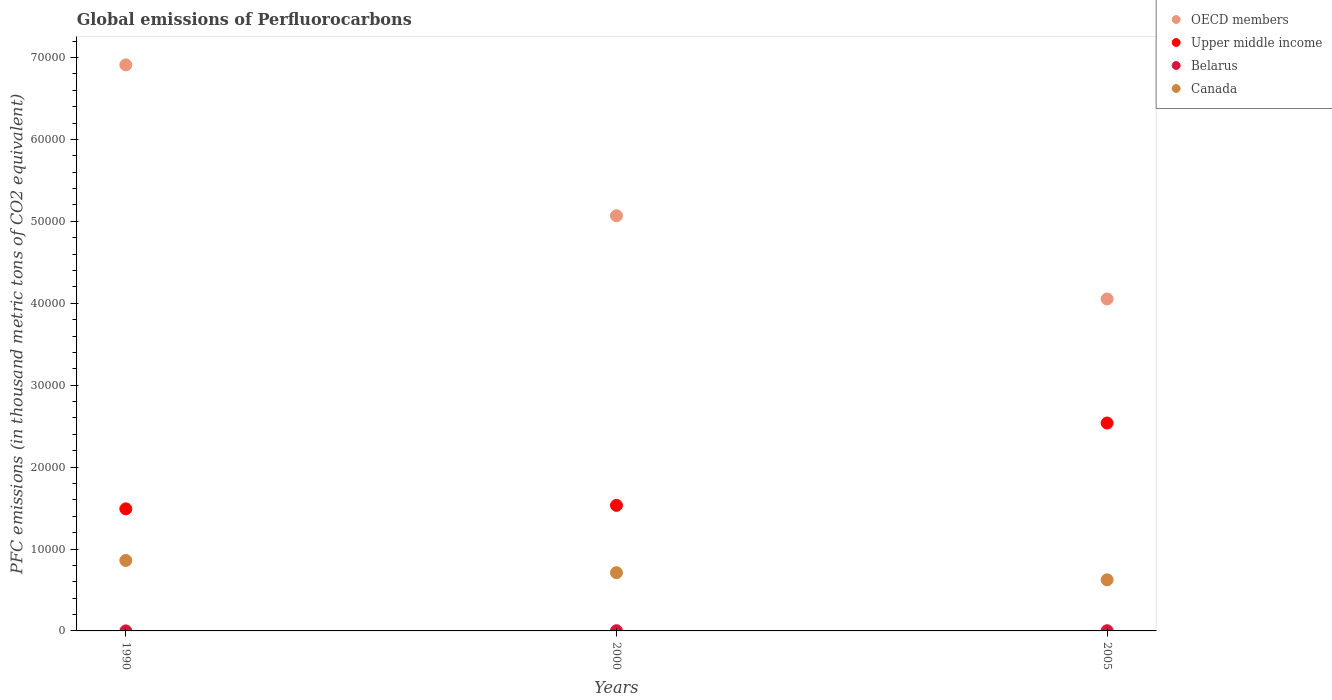Is the number of dotlines equal to the number of legend labels?
Keep it short and to the point. Yes. What is the global emissions of Perfluorocarbons in Belarus in 2005?
Your answer should be very brief. 23.4. Across all years, what is the maximum global emissions of Perfluorocarbons in Belarus?
Your answer should be very brief. 23.9. Across all years, what is the minimum global emissions of Perfluorocarbons in Upper middle income?
Provide a short and direct response. 1.49e+04. In which year was the global emissions of Perfluorocarbons in Belarus maximum?
Your answer should be compact. 2000. In which year was the global emissions of Perfluorocarbons in Canada minimum?
Your answer should be very brief. 2005. What is the total global emissions of Perfluorocarbons in Upper middle income in the graph?
Provide a short and direct response. 5.56e+04. What is the difference between the global emissions of Perfluorocarbons in Canada in 2000 and that in 2005?
Offer a terse response. 871.9. What is the difference between the global emissions of Perfluorocarbons in Canada in 2005 and the global emissions of Perfluorocarbons in Upper middle income in 1990?
Keep it short and to the point. -8662.6. What is the average global emissions of Perfluorocarbons in Upper middle income per year?
Your response must be concise. 1.85e+04. In the year 1990, what is the difference between the global emissions of Perfluorocarbons in Belarus and global emissions of Perfluorocarbons in OECD members?
Your response must be concise. -6.91e+04. In how many years, is the global emissions of Perfluorocarbons in Belarus greater than 20000 thousand metric tons?
Your response must be concise. 0. What is the ratio of the global emissions of Perfluorocarbons in Upper middle income in 2000 to that in 2005?
Provide a short and direct response. 0.6. Is the difference between the global emissions of Perfluorocarbons in Belarus in 1990 and 2005 greater than the difference between the global emissions of Perfluorocarbons in OECD members in 1990 and 2005?
Provide a short and direct response. No. What is the difference between the highest and the second highest global emissions of Perfluorocarbons in Upper middle income?
Ensure brevity in your answer.  1.01e+04. What is the difference between the highest and the lowest global emissions of Perfluorocarbons in Upper middle income?
Provide a succinct answer. 1.05e+04. Is it the case that in every year, the sum of the global emissions of Perfluorocarbons in Upper middle income and global emissions of Perfluorocarbons in Belarus  is greater than the sum of global emissions of Perfluorocarbons in OECD members and global emissions of Perfluorocarbons in Canada?
Keep it short and to the point. No. Is it the case that in every year, the sum of the global emissions of Perfluorocarbons in Belarus and global emissions of Perfluorocarbons in OECD members  is greater than the global emissions of Perfluorocarbons in Upper middle income?
Provide a succinct answer. Yes. Does the global emissions of Perfluorocarbons in Canada monotonically increase over the years?
Make the answer very short. No. Is the global emissions of Perfluorocarbons in Belarus strictly less than the global emissions of Perfluorocarbons in OECD members over the years?
Offer a terse response. Yes. How many dotlines are there?
Offer a terse response. 4. How many years are there in the graph?
Give a very brief answer. 3. What is the difference between two consecutive major ticks on the Y-axis?
Offer a very short reply. 10000. Are the values on the major ticks of Y-axis written in scientific E-notation?
Ensure brevity in your answer.  No. Does the graph contain grids?
Provide a short and direct response. No. Where does the legend appear in the graph?
Your response must be concise. Top right. What is the title of the graph?
Your response must be concise. Global emissions of Perfluorocarbons. Does "World" appear as one of the legend labels in the graph?
Provide a short and direct response. No. What is the label or title of the Y-axis?
Ensure brevity in your answer.  PFC emissions (in thousand metric tons of CO2 equivalent). What is the PFC emissions (in thousand metric tons of CO2 equivalent) of OECD members in 1990?
Make the answer very short. 6.91e+04. What is the PFC emissions (in thousand metric tons of CO2 equivalent) of Upper middle income in 1990?
Make the answer very short. 1.49e+04. What is the PFC emissions (in thousand metric tons of CO2 equivalent) in Belarus in 1990?
Give a very brief answer. 2.6. What is the PFC emissions (in thousand metric tons of CO2 equivalent) of Canada in 1990?
Offer a very short reply. 8600.3. What is the PFC emissions (in thousand metric tons of CO2 equivalent) of OECD members in 2000?
Offer a terse response. 5.07e+04. What is the PFC emissions (in thousand metric tons of CO2 equivalent) of Upper middle income in 2000?
Give a very brief answer. 1.53e+04. What is the PFC emissions (in thousand metric tons of CO2 equivalent) in Belarus in 2000?
Give a very brief answer. 23.9. What is the PFC emissions (in thousand metric tons of CO2 equivalent) in Canada in 2000?
Offer a very short reply. 7109.9. What is the PFC emissions (in thousand metric tons of CO2 equivalent) in OECD members in 2005?
Keep it short and to the point. 4.05e+04. What is the PFC emissions (in thousand metric tons of CO2 equivalent) of Upper middle income in 2005?
Your answer should be compact. 2.54e+04. What is the PFC emissions (in thousand metric tons of CO2 equivalent) in Belarus in 2005?
Provide a short and direct response. 23.4. What is the PFC emissions (in thousand metric tons of CO2 equivalent) in Canada in 2005?
Your answer should be compact. 6238. Across all years, what is the maximum PFC emissions (in thousand metric tons of CO2 equivalent) in OECD members?
Provide a short and direct response. 6.91e+04. Across all years, what is the maximum PFC emissions (in thousand metric tons of CO2 equivalent) in Upper middle income?
Provide a short and direct response. 2.54e+04. Across all years, what is the maximum PFC emissions (in thousand metric tons of CO2 equivalent) of Belarus?
Your response must be concise. 23.9. Across all years, what is the maximum PFC emissions (in thousand metric tons of CO2 equivalent) of Canada?
Provide a short and direct response. 8600.3. Across all years, what is the minimum PFC emissions (in thousand metric tons of CO2 equivalent) in OECD members?
Make the answer very short. 4.05e+04. Across all years, what is the minimum PFC emissions (in thousand metric tons of CO2 equivalent) of Upper middle income?
Provide a short and direct response. 1.49e+04. Across all years, what is the minimum PFC emissions (in thousand metric tons of CO2 equivalent) in Canada?
Provide a short and direct response. 6238. What is the total PFC emissions (in thousand metric tons of CO2 equivalent) in OECD members in the graph?
Ensure brevity in your answer.  1.60e+05. What is the total PFC emissions (in thousand metric tons of CO2 equivalent) of Upper middle income in the graph?
Give a very brief answer. 5.56e+04. What is the total PFC emissions (in thousand metric tons of CO2 equivalent) in Belarus in the graph?
Offer a very short reply. 49.9. What is the total PFC emissions (in thousand metric tons of CO2 equivalent) in Canada in the graph?
Ensure brevity in your answer.  2.19e+04. What is the difference between the PFC emissions (in thousand metric tons of CO2 equivalent) of OECD members in 1990 and that in 2000?
Provide a succinct answer. 1.84e+04. What is the difference between the PFC emissions (in thousand metric tons of CO2 equivalent) of Upper middle income in 1990 and that in 2000?
Keep it short and to the point. -426.2. What is the difference between the PFC emissions (in thousand metric tons of CO2 equivalent) in Belarus in 1990 and that in 2000?
Provide a short and direct response. -21.3. What is the difference between the PFC emissions (in thousand metric tons of CO2 equivalent) of Canada in 1990 and that in 2000?
Give a very brief answer. 1490.4. What is the difference between the PFC emissions (in thousand metric tons of CO2 equivalent) in OECD members in 1990 and that in 2005?
Your answer should be compact. 2.86e+04. What is the difference between the PFC emissions (in thousand metric tons of CO2 equivalent) in Upper middle income in 1990 and that in 2005?
Your answer should be very brief. -1.05e+04. What is the difference between the PFC emissions (in thousand metric tons of CO2 equivalent) in Belarus in 1990 and that in 2005?
Ensure brevity in your answer.  -20.8. What is the difference between the PFC emissions (in thousand metric tons of CO2 equivalent) of Canada in 1990 and that in 2005?
Your answer should be very brief. 2362.3. What is the difference between the PFC emissions (in thousand metric tons of CO2 equivalent) of OECD members in 2000 and that in 2005?
Provide a short and direct response. 1.02e+04. What is the difference between the PFC emissions (in thousand metric tons of CO2 equivalent) in Upper middle income in 2000 and that in 2005?
Your response must be concise. -1.01e+04. What is the difference between the PFC emissions (in thousand metric tons of CO2 equivalent) of Canada in 2000 and that in 2005?
Give a very brief answer. 871.9. What is the difference between the PFC emissions (in thousand metric tons of CO2 equivalent) in OECD members in 1990 and the PFC emissions (in thousand metric tons of CO2 equivalent) in Upper middle income in 2000?
Your response must be concise. 5.38e+04. What is the difference between the PFC emissions (in thousand metric tons of CO2 equivalent) in OECD members in 1990 and the PFC emissions (in thousand metric tons of CO2 equivalent) in Belarus in 2000?
Make the answer very short. 6.91e+04. What is the difference between the PFC emissions (in thousand metric tons of CO2 equivalent) in OECD members in 1990 and the PFC emissions (in thousand metric tons of CO2 equivalent) in Canada in 2000?
Ensure brevity in your answer.  6.20e+04. What is the difference between the PFC emissions (in thousand metric tons of CO2 equivalent) of Upper middle income in 1990 and the PFC emissions (in thousand metric tons of CO2 equivalent) of Belarus in 2000?
Make the answer very short. 1.49e+04. What is the difference between the PFC emissions (in thousand metric tons of CO2 equivalent) in Upper middle income in 1990 and the PFC emissions (in thousand metric tons of CO2 equivalent) in Canada in 2000?
Keep it short and to the point. 7790.7. What is the difference between the PFC emissions (in thousand metric tons of CO2 equivalent) in Belarus in 1990 and the PFC emissions (in thousand metric tons of CO2 equivalent) in Canada in 2000?
Keep it short and to the point. -7107.3. What is the difference between the PFC emissions (in thousand metric tons of CO2 equivalent) of OECD members in 1990 and the PFC emissions (in thousand metric tons of CO2 equivalent) of Upper middle income in 2005?
Your response must be concise. 4.37e+04. What is the difference between the PFC emissions (in thousand metric tons of CO2 equivalent) in OECD members in 1990 and the PFC emissions (in thousand metric tons of CO2 equivalent) in Belarus in 2005?
Make the answer very short. 6.91e+04. What is the difference between the PFC emissions (in thousand metric tons of CO2 equivalent) of OECD members in 1990 and the PFC emissions (in thousand metric tons of CO2 equivalent) of Canada in 2005?
Give a very brief answer. 6.29e+04. What is the difference between the PFC emissions (in thousand metric tons of CO2 equivalent) of Upper middle income in 1990 and the PFC emissions (in thousand metric tons of CO2 equivalent) of Belarus in 2005?
Offer a very short reply. 1.49e+04. What is the difference between the PFC emissions (in thousand metric tons of CO2 equivalent) in Upper middle income in 1990 and the PFC emissions (in thousand metric tons of CO2 equivalent) in Canada in 2005?
Provide a short and direct response. 8662.6. What is the difference between the PFC emissions (in thousand metric tons of CO2 equivalent) in Belarus in 1990 and the PFC emissions (in thousand metric tons of CO2 equivalent) in Canada in 2005?
Provide a succinct answer. -6235.4. What is the difference between the PFC emissions (in thousand metric tons of CO2 equivalent) of OECD members in 2000 and the PFC emissions (in thousand metric tons of CO2 equivalent) of Upper middle income in 2005?
Offer a very short reply. 2.53e+04. What is the difference between the PFC emissions (in thousand metric tons of CO2 equivalent) in OECD members in 2000 and the PFC emissions (in thousand metric tons of CO2 equivalent) in Belarus in 2005?
Offer a very short reply. 5.07e+04. What is the difference between the PFC emissions (in thousand metric tons of CO2 equivalent) in OECD members in 2000 and the PFC emissions (in thousand metric tons of CO2 equivalent) in Canada in 2005?
Your response must be concise. 4.44e+04. What is the difference between the PFC emissions (in thousand metric tons of CO2 equivalent) in Upper middle income in 2000 and the PFC emissions (in thousand metric tons of CO2 equivalent) in Belarus in 2005?
Your answer should be compact. 1.53e+04. What is the difference between the PFC emissions (in thousand metric tons of CO2 equivalent) of Upper middle income in 2000 and the PFC emissions (in thousand metric tons of CO2 equivalent) of Canada in 2005?
Your response must be concise. 9088.8. What is the difference between the PFC emissions (in thousand metric tons of CO2 equivalent) of Belarus in 2000 and the PFC emissions (in thousand metric tons of CO2 equivalent) of Canada in 2005?
Your response must be concise. -6214.1. What is the average PFC emissions (in thousand metric tons of CO2 equivalent) of OECD members per year?
Make the answer very short. 5.34e+04. What is the average PFC emissions (in thousand metric tons of CO2 equivalent) of Upper middle income per year?
Offer a very short reply. 1.85e+04. What is the average PFC emissions (in thousand metric tons of CO2 equivalent) of Belarus per year?
Offer a very short reply. 16.63. What is the average PFC emissions (in thousand metric tons of CO2 equivalent) of Canada per year?
Your answer should be very brief. 7316.07. In the year 1990, what is the difference between the PFC emissions (in thousand metric tons of CO2 equivalent) of OECD members and PFC emissions (in thousand metric tons of CO2 equivalent) of Upper middle income?
Your response must be concise. 5.42e+04. In the year 1990, what is the difference between the PFC emissions (in thousand metric tons of CO2 equivalent) of OECD members and PFC emissions (in thousand metric tons of CO2 equivalent) of Belarus?
Your response must be concise. 6.91e+04. In the year 1990, what is the difference between the PFC emissions (in thousand metric tons of CO2 equivalent) of OECD members and PFC emissions (in thousand metric tons of CO2 equivalent) of Canada?
Your answer should be very brief. 6.05e+04. In the year 1990, what is the difference between the PFC emissions (in thousand metric tons of CO2 equivalent) in Upper middle income and PFC emissions (in thousand metric tons of CO2 equivalent) in Belarus?
Make the answer very short. 1.49e+04. In the year 1990, what is the difference between the PFC emissions (in thousand metric tons of CO2 equivalent) of Upper middle income and PFC emissions (in thousand metric tons of CO2 equivalent) of Canada?
Offer a terse response. 6300.3. In the year 1990, what is the difference between the PFC emissions (in thousand metric tons of CO2 equivalent) of Belarus and PFC emissions (in thousand metric tons of CO2 equivalent) of Canada?
Your response must be concise. -8597.7. In the year 2000, what is the difference between the PFC emissions (in thousand metric tons of CO2 equivalent) of OECD members and PFC emissions (in thousand metric tons of CO2 equivalent) of Upper middle income?
Your answer should be very brief. 3.54e+04. In the year 2000, what is the difference between the PFC emissions (in thousand metric tons of CO2 equivalent) of OECD members and PFC emissions (in thousand metric tons of CO2 equivalent) of Belarus?
Ensure brevity in your answer.  5.07e+04. In the year 2000, what is the difference between the PFC emissions (in thousand metric tons of CO2 equivalent) in OECD members and PFC emissions (in thousand metric tons of CO2 equivalent) in Canada?
Keep it short and to the point. 4.36e+04. In the year 2000, what is the difference between the PFC emissions (in thousand metric tons of CO2 equivalent) of Upper middle income and PFC emissions (in thousand metric tons of CO2 equivalent) of Belarus?
Your answer should be very brief. 1.53e+04. In the year 2000, what is the difference between the PFC emissions (in thousand metric tons of CO2 equivalent) of Upper middle income and PFC emissions (in thousand metric tons of CO2 equivalent) of Canada?
Your answer should be compact. 8216.9. In the year 2000, what is the difference between the PFC emissions (in thousand metric tons of CO2 equivalent) of Belarus and PFC emissions (in thousand metric tons of CO2 equivalent) of Canada?
Offer a terse response. -7086. In the year 2005, what is the difference between the PFC emissions (in thousand metric tons of CO2 equivalent) in OECD members and PFC emissions (in thousand metric tons of CO2 equivalent) in Upper middle income?
Offer a terse response. 1.51e+04. In the year 2005, what is the difference between the PFC emissions (in thousand metric tons of CO2 equivalent) of OECD members and PFC emissions (in thousand metric tons of CO2 equivalent) of Belarus?
Give a very brief answer. 4.05e+04. In the year 2005, what is the difference between the PFC emissions (in thousand metric tons of CO2 equivalent) in OECD members and PFC emissions (in thousand metric tons of CO2 equivalent) in Canada?
Offer a terse response. 3.43e+04. In the year 2005, what is the difference between the PFC emissions (in thousand metric tons of CO2 equivalent) of Upper middle income and PFC emissions (in thousand metric tons of CO2 equivalent) of Belarus?
Your answer should be very brief. 2.54e+04. In the year 2005, what is the difference between the PFC emissions (in thousand metric tons of CO2 equivalent) in Upper middle income and PFC emissions (in thousand metric tons of CO2 equivalent) in Canada?
Provide a succinct answer. 1.91e+04. In the year 2005, what is the difference between the PFC emissions (in thousand metric tons of CO2 equivalent) in Belarus and PFC emissions (in thousand metric tons of CO2 equivalent) in Canada?
Your answer should be compact. -6214.6. What is the ratio of the PFC emissions (in thousand metric tons of CO2 equivalent) in OECD members in 1990 to that in 2000?
Give a very brief answer. 1.36. What is the ratio of the PFC emissions (in thousand metric tons of CO2 equivalent) in Upper middle income in 1990 to that in 2000?
Make the answer very short. 0.97. What is the ratio of the PFC emissions (in thousand metric tons of CO2 equivalent) of Belarus in 1990 to that in 2000?
Your answer should be very brief. 0.11. What is the ratio of the PFC emissions (in thousand metric tons of CO2 equivalent) in Canada in 1990 to that in 2000?
Provide a succinct answer. 1.21. What is the ratio of the PFC emissions (in thousand metric tons of CO2 equivalent) in OECD members in 1990 to that in 2005?
Offer a terse response. 1.71. What is the ratio of the PFC emissions (in thousand metric tons of CO2 equivalent) of Upper middle income in 1990 to that in 2005?
Provide a succinct answer. 0.59. What is the ratio of the PFC emissions (in thousand metric tons of CO2 equivalent) of Belarus in 1990 to that in 2005?
Your answer should be compact. 0.11. What is the ratio of the PFC emissions (in thousand metric tons of CO2 equivalent) of Canada in 1990 to that in 2005?
Make the answer very short. 1.38. What is the ratio of the PFC emissions (in thousand metric tons of CO2 equivalent) of OECD members in 2000 to that in 2005?
Give a very brief answer. 1.25. What is the ratio of the PFC emissions (in thousand metric tons of CO2 equivalent) in Upper middle income in 2000 to that in 2005?
Provide a succinct answer. 0.6. What is the ratio of the PFC emissions (in thousand metric tons of CO2 equivalent) of Belarus in 2000 to that in 2005?
Keep it short and to the point. 1.02. What is the ratio of the PFC emissions (in thousand metric tons of CO2 equivalent) of Canada in 2000 to that in 2005?
Offer a very short reply. 1.14. What is the difference between the highest and the second highest PFC emissions (in thousand metric tons of CO2 equivalent) in OECD members?
Your answer should be compact. 1.84e+04. What is the difference between the highest and the second highest PFC emissions (in thousand metric tons of CO2 equivalent) in Upper middle income?
Provide a short and direct response. 1.01e+04. What is the difference between the highest and the second highest PFC emissions (in thousand metric tons of CO2 equivalent) in Belarus?
Ensure brevity in your answer.  0.5. What is the difference between the highest and the second highest PFC emissions (in thousand metric tons of CO2 equivalent) of Canada?
Offer a very short reply. 1490.4. What is the difference between the highest and the lowest PFC emissions (in thousand metric tons of CO2 equivalent) of OECD members?
Offer a very short reply. 2.86e+04. What is the difference between the highest and the lowest PFC emissions (in thousand metric tons of CO2 equivalent) in Upper middle income?
Your answer should be very brief. 1.05e+04. What is the difference between the highest and the lowest PFC emissions (in thousand metric tons of CO2 equivalent) in Belarus?
Ensure brevity in your answer.  21.3. What is the difference between the highest and the lowest PFC emissions (in thousand metric tons of CO2 equivalent) of Canada?
Provide a succinct answer. 2362.3. 